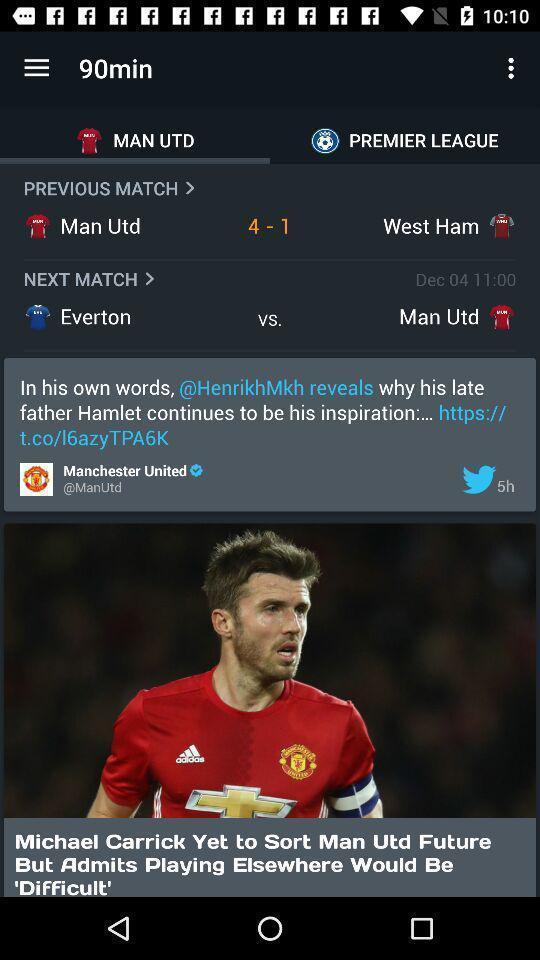Describe the visual elements of this screenshot. Screen shows score details in a sports app. 